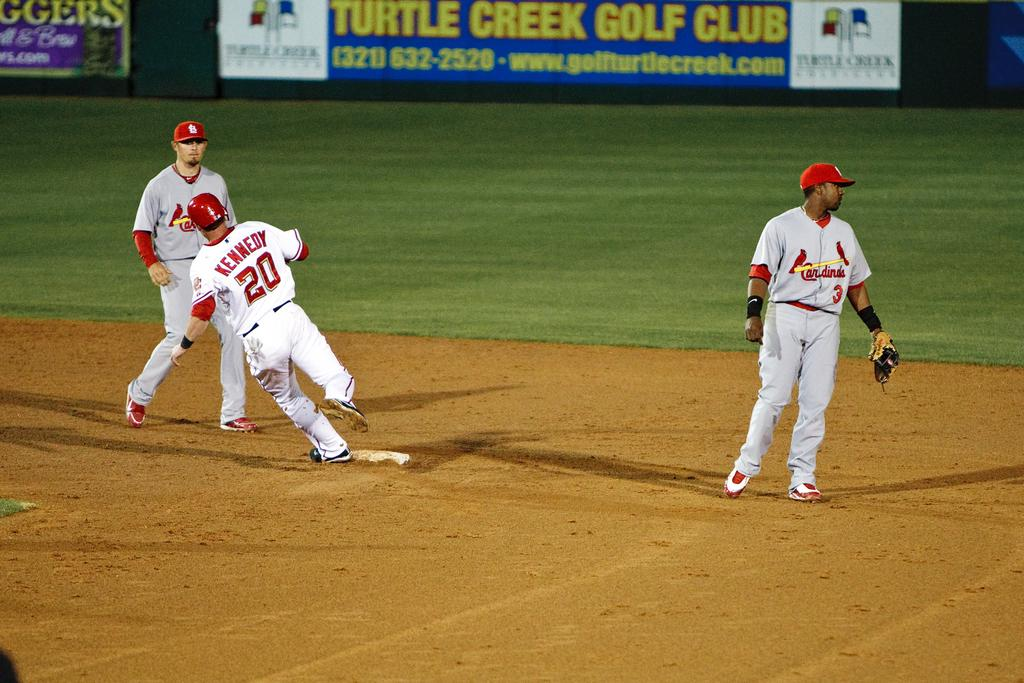<image>
Present a compact description of the photo's key features. Turtle Creek Golf Club is advertised at this basball field. 